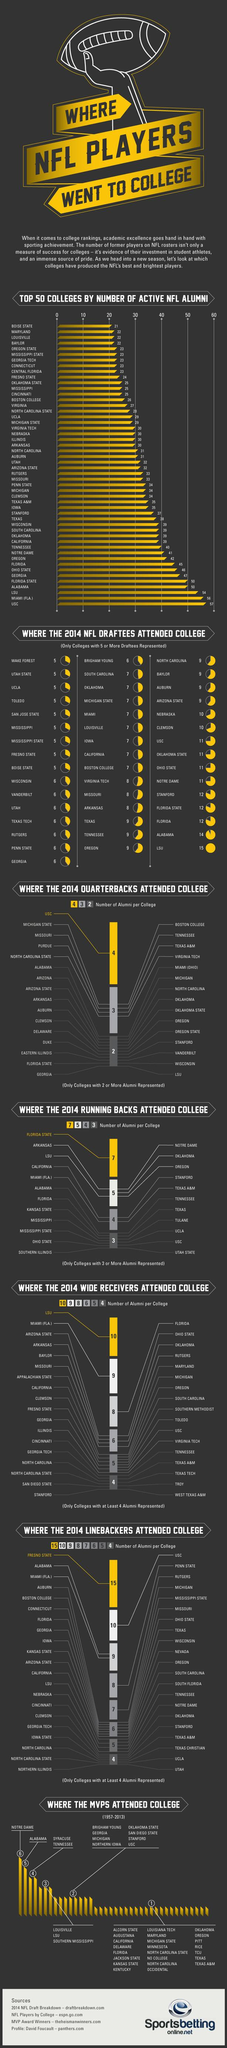Point out several critical features in this image. Florida State University had the highest number of 2014 running backs attend their college. In 2014, the college with the most NFL Draftees was LSU. The number of active NFL alumni from USC and Miami (Fla) combined is 113. In 2014, the most number of quarterbacks attended the University of Southern California (USC). Out of all the colleges, how many had at least 4 MVPs attend? 